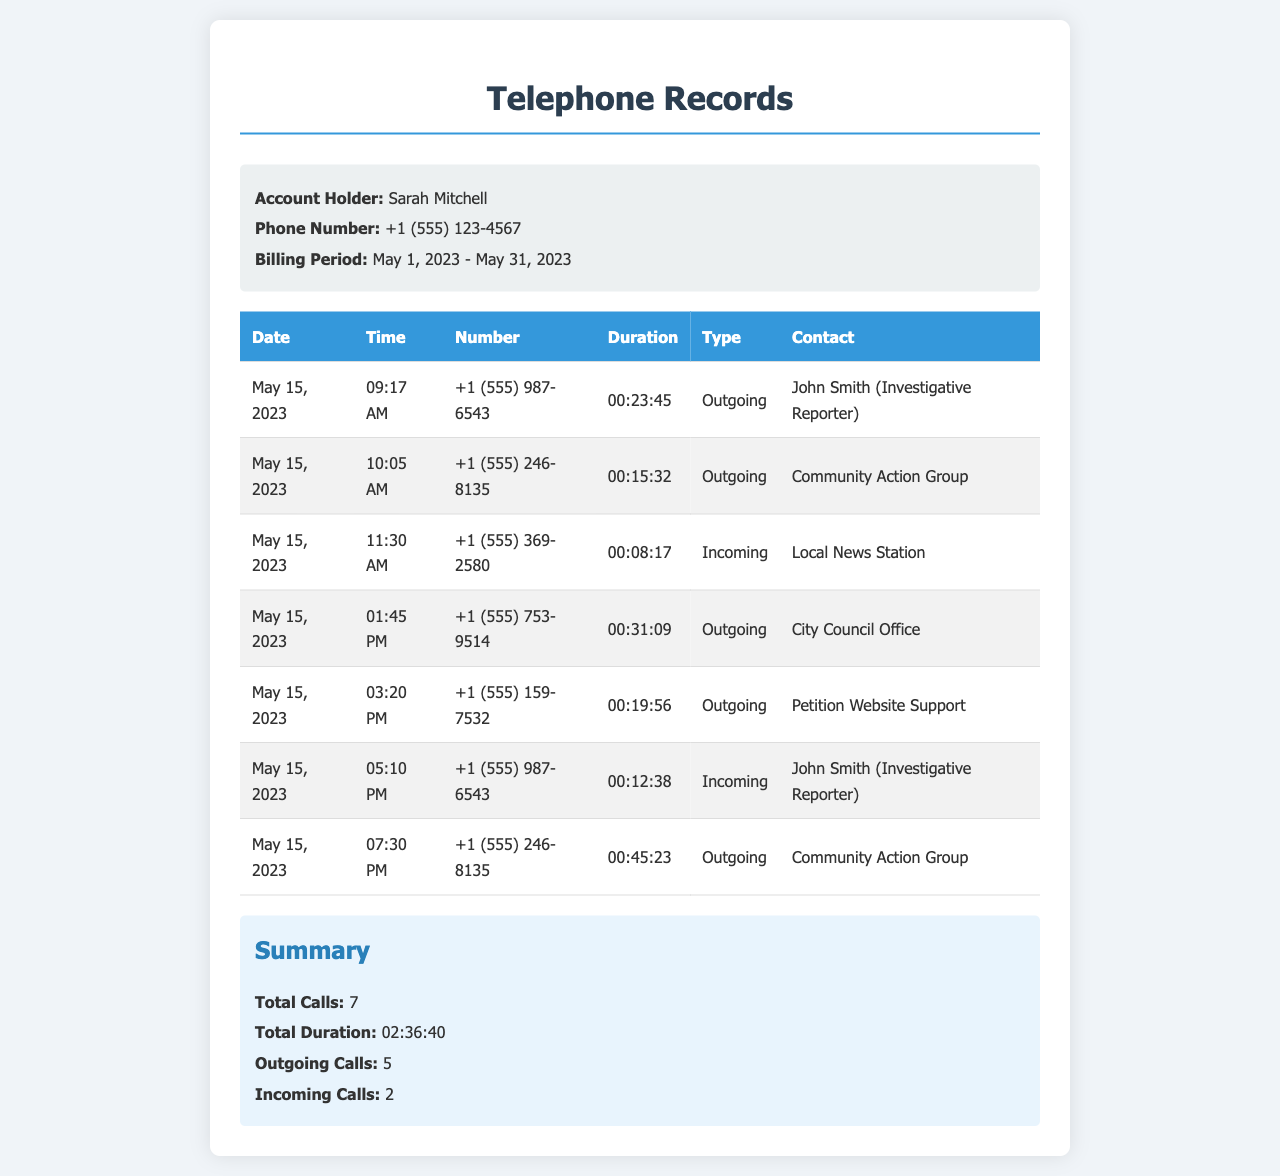what is the account holder's name? The account holder's name is stated in the "Account Holder" section of the document.
Answer: Sarah Mitchell what is the billing period? The billing period is specified in the document's header under "Billing Period."
Answer: May 1, 2023 - May 31, 2023 how many total calls were made? The total number of calls is summarized at the end of the document.
Answer: 7 what is the longest call duration? The call with the longest duration is noted in the table; it is the call to the City Council Office.
Answer: 00:31:09 how many outgoing calls were made on May 15, 2023? Outgoing calls can be counted from the entries in the table for that date.
Answer: 5 which contact was reached the most on May 15, 2023? The contact with the most calls can be deduced from the frequency of calls listed in the table.
Answer: Community Action Group how many incoming calls were recorded? This information is provided in the summary at the bottom of the document.
Answer: 2 what type of document is this? The document is identified as telephone records, as indicated in the title.
Answer: Telephone Records 